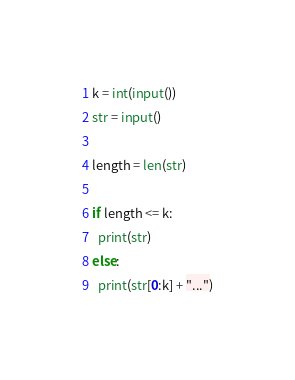<code> <loc_0><loc_0><loc_500><loc_500><_Python_>k = int(input())
str = input()

length = len(str)

if length <= k:
  print(str)
else:
  print(str[0:k] + "...")</code> 